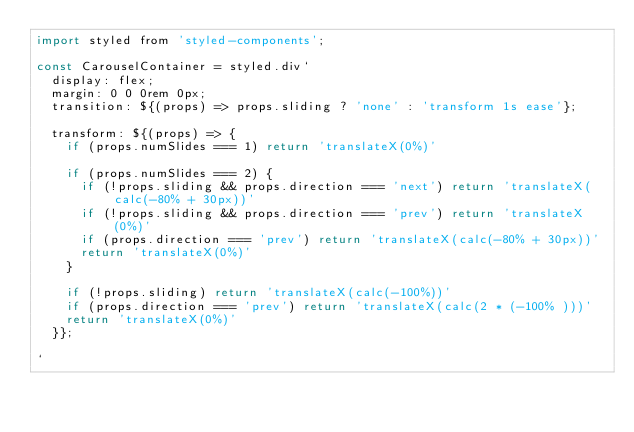<code> <loc_0><loc_0><loc_500><loc_500><_JavaScript_>import styled from 'styled-components';

const CarouselContainer = styled.div`
  display: flex;
  margin: 0 0 0rem 0px;
  transition: ${(props) => props.sliding ? 'none' : 'transform 1s ease'};

  transform: ${(props) => {
    if (props.numSlides === 1) return 'translateX(0%)'

    if (props.numSlides === 2) {
      if (!props.sliding && props.direction === 'next') return 'translateX(calc(-80% + 30px))'
      if (!props.sliding && props.direction === 'prev') return 'translateX(0%)'
      if (props.direction === 'prev') return 'translateX(calc(-80% + 30px))'
      return 'translateX(0%)'
    }

    if (!props.sliding) return 'translateX(calc(-100%))'
    if (props.direction === 'prev') return 'translateX(calc(2 * (-100% )))'
    return 'translateX(0%)'
  }};
  
`
</code> 